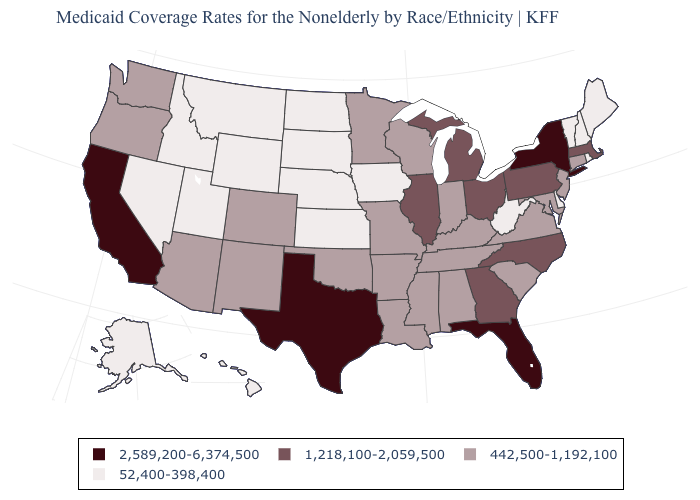Which states have the lowest value in the MidWest?
Be succinct. Iowa, Kansas, Nebraska, North Dakota, South Dakota. What is the value of Idaho?
Answer briefly. 52,400-398,400. Is the legend a continuous bar?
Quick response, please. No. Which states have the highest value in the USA?
Give a very brief answer. California, Florida, New York, Texas. Does Mississippi have a higher value than Louisiana?
Be succinct. No. What is the value of South Carolina?
Give a very brief answer. 442,500-1,192,100. Which states have the lowest value in the USA?
Short answer required. Alaska, Delaware, Hawaii, Idaho, Iowa, Kansas, Maine, Montana, Nebraska, Nevada, New Hampshire, North Dakota, Rhode Island, South Dakota, Utah, Vermont, West Virginia, Wyoming. What is the value of Washington?
Write a very short answer. 442,500-1,192,100. What is the lowest value in the South?
Quick response, please. 52,400-398,400. Name the states that have a value in the range 442,500-1,192,100?
Concise answer only. Alabama, Arizona, Arkansas, Colorado, Connecticut, Indiana, Kentucky, Louisiana, Maryland, Minnesota, Mississippi, Missouri, New Jersey, New Mexico, Oklahoma, Oregon, South Carolina, Tennessee, Virginia, Washington, Wisconsin. Does Maryland have the lowest value in the South?
Be succinct. No. What is the value of Nebraska?
Be succinct. 52,400-398,400. Name the states that have a value in the range 2,589,200-6,374,500?
Be succinct. California, Florida, New York, Texas. What is the value of Ohio?
Be succinct. 1,218,100-2,059,500. 